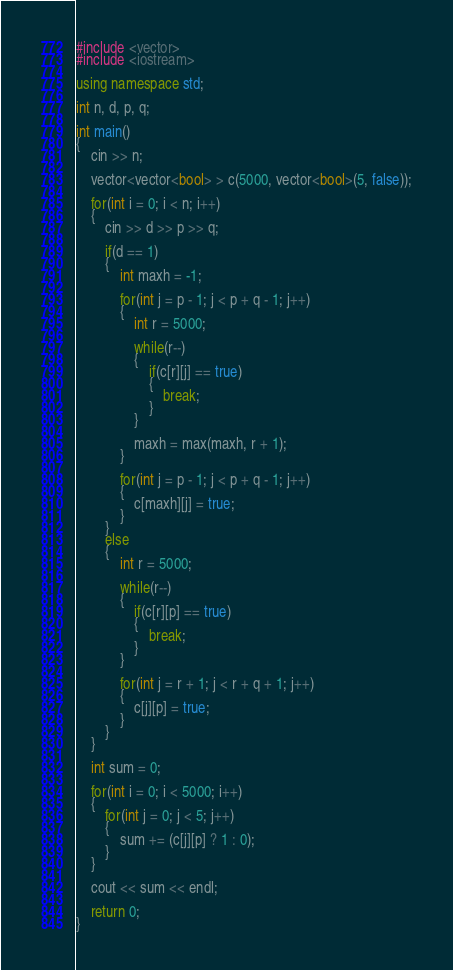Convert code to text. <code><loc_0><loc_0><loc_500><loc_500><_C++_>#include <vector>
#include <iostream>

using namespace std;

int n, d, p, q;

int main()
{
    cin >> n;
    
    vector<vector<bool> > c(5000, vector<bool>(5, false));
    
    for(int i = 0; i < n; i++)
    {
        cin >> d >> p >> q;
        
        if(d == 1)
        {
            int maxh = -1;
            
            for(int j = p - 1; j < p + q - 1; j++)
            {
                int r = 5000;
                
                while(r--)
                {
                    if(c[r][j] == true)
                    {
                        break;
                    }
                }
                
                maxh = max(maxh, r + 1);
            }
            
            for(int j = p - 1; j < p + q - 1; j++)
            {
                c[maxh][j] = true;
            }
        }
        else
        {
            int r = 5000;
            
            while(r--)
            {
                if(c[r][p] == true)
                {
                    break;
                }
            }
            
            for(int j = r + 1; j < r + q + 1; j++)
            {
                c[j][p] = true;
            }
        }
    }
    
    int sum = 0;
    
    for(int i = 0; i < 5000; i++)
    {
        for(int j = 0; j < 5; j++)
        {
            sum += (c[j][p] ? 1 : 0);
        }
    }
    
    cout << sum << endl;
    
    return 0;
}</code> 